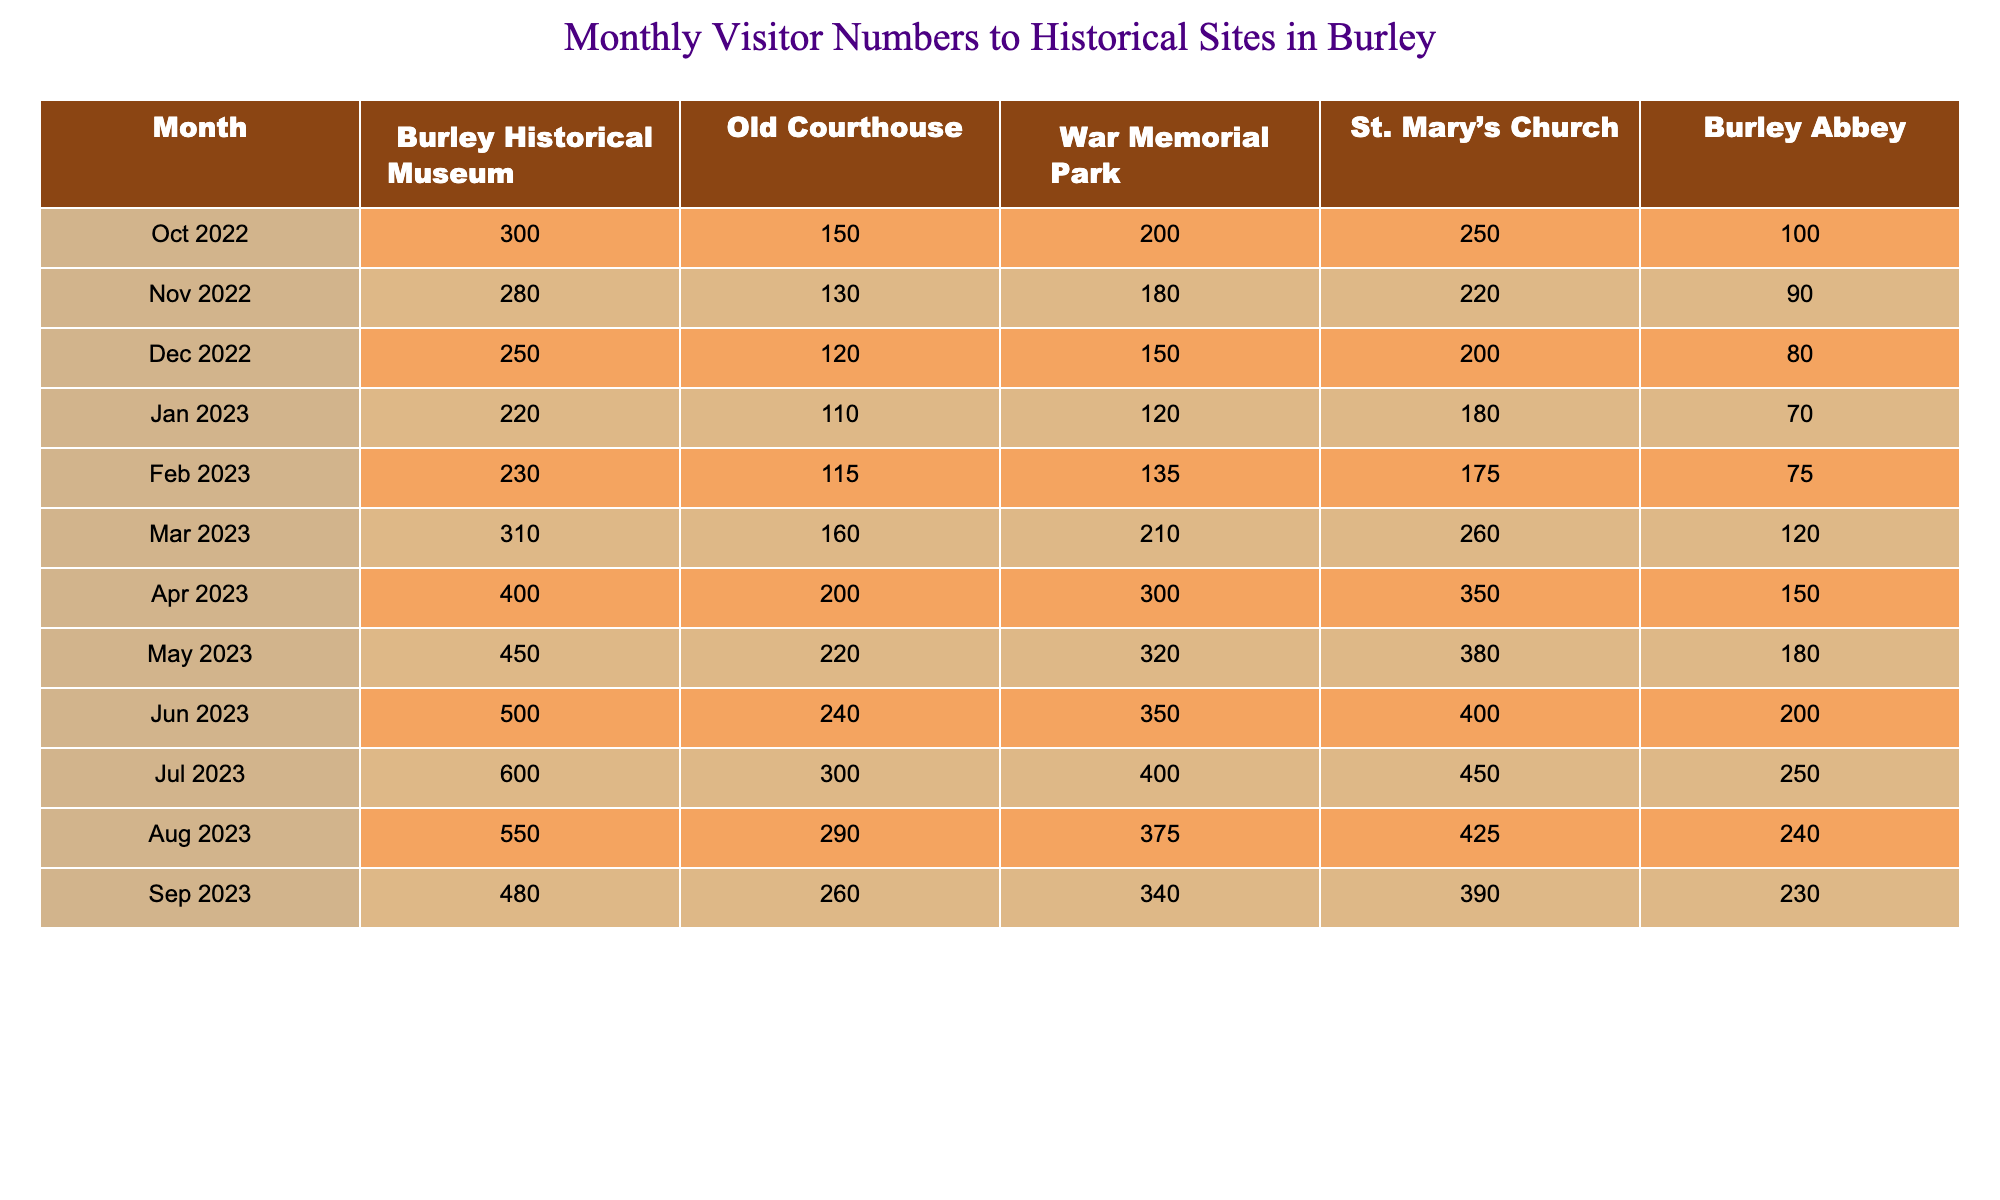What was the total number of visitors to Burley Abbey in July 2023? In July 2023, the number of visitors to Burley Abbey is listed as 250. Thus, the total number of visitors for that month is directly taken from the table.
Answer: 250 Which month had the highest number of visitors at the Old Courthouse? Referring to the table, July 2023 shows the highest visitor count at the Old Courthouse with 300 visitors. By comparing all the months, this is the highest number recorded for that site.
Answer: July 2023 What was the average number of visitors across all sites in August 2023? In August 2023, the total visitors for all sites are calculated as follows: 550 (Museum) + 290 (Courthouse) + 375 (Park) + 425 (Church) + 240 (Abbey) = 1870. Dividing this by the 5 sites gives an average of 374.
Answer: 374 Did Burley Historical Museum see an increase in visitors from October 2022 to October 2023? Comparing October 2022 (300 visitors) and the last month available (September 2023), which shows 480 visitors at the Museum. This indicates an increase.
Answer: Yes What is the difference in visitors between the War Memorial Park in April and the previous month, March? In April 2023, War Memorial Park had 300 visitors, while March had 210 visitors. The difference is calculated as 300 - 210 = 90.
Answer: 90 Which historical site experienced the highest growth in visitors from January 2023 to June 2023? The visitors increased from January to June for each site: Museum (220 to 500), Courthouse (110 to 240), Park (120 to 350), Church (180 to 400), Abbey (70 to 200). The Burley Historical Museum had the highest increase of 280 visitors.
Answer: Burley Historical Museum What percentage of visitors to St. Mary’s Church in December 2022 were there compared to the highest month recorded for the site? The highest visitor month for St. Mary’s Church is April 2023 with 350 visitors; December 2022 had 200 visitors. The percentage is calculated as (200/350) * 100 = 57.14%.
Answer: 57.14% In which month did the total number of visitors across all sites exceed 1500? By summing the total visitors across all sites for each month, we find that in June 2023, the total is 500 + 240 + 350 + 400 + 200 = 1690, which exceeds 1500 for the first time in that year.
Answer: June 2023 How many visitors did both the Old Courthouse and War Memorial Park have combined in May 2023? In May 2023, the Old Courthouse had 220 visitors and War Memorial Park had 320 visitors. Their combined total is calculated as 220 + 320 = 540.
Answer: 540 Is there a month where all historical sites saw more visitors compared to the previous month? Examining the visitor data month by month, April 2023 shows an increase for all sites compared to March, marking it as a month of enhanced visitor interest across the board.
Answer: Yes Which month had a decrease in visitors at the Burley Abbey compared to the previous month? Reviewing the data, in July 2023, Burley Abbey had 250 visitors, while June 2023 had 200 visitors, indicating an increase. However, from August 2023 with 240 visitors, there was a drop from the previous month of July.
Answer: August 2023 